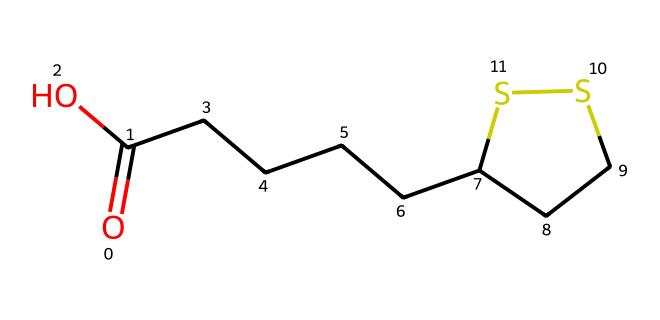What is the molecular formula of lipoic acid? The structure shows the atom count: 8 carbon (C) atoms, 14 hydrogen (H) atoms, 2 oxygen (O) atoms, and 1 sulfur (S) atom in total, which gives the molecular formula C8H14O2S2.
Answer: C8H14O2S2 How many sulfur atoms are present in this molecule? By examining the structure, we can identify that there are 2 sulfur (S) atoms in the molecular arrangement.
Answer: 2 What type of functional groups are present in lipoic acid? Analyzing the structure reveals a carboxylic acid group (-COOH) and the presence of sulfur atoms that indicate potential thiol functional groups.
Answer: carboxylic acid and thiol What is the total number of rings in this molecular structure? The chemical structure contains one cyclic part, which is indicated by the ring denoted in the structure (specifically a 5-membered ring involving the sulfur atoms).
Answer: 1 What role does lipoic acid play in oxidative stress? Lipoic acid acts as an antioxidant, scavenging free radicals and thereby offering protection against oxidative stress.
Answer: antioxidant How does the presence of sulfur contribute to the properties of lipoic acid? The sulfur atoms in the structure contribute to redox reactions, allowing lipoic acid to regenerate other antioxidants, enhancing its function as an antioxidant.
Answer: regeneration of antioxidants 